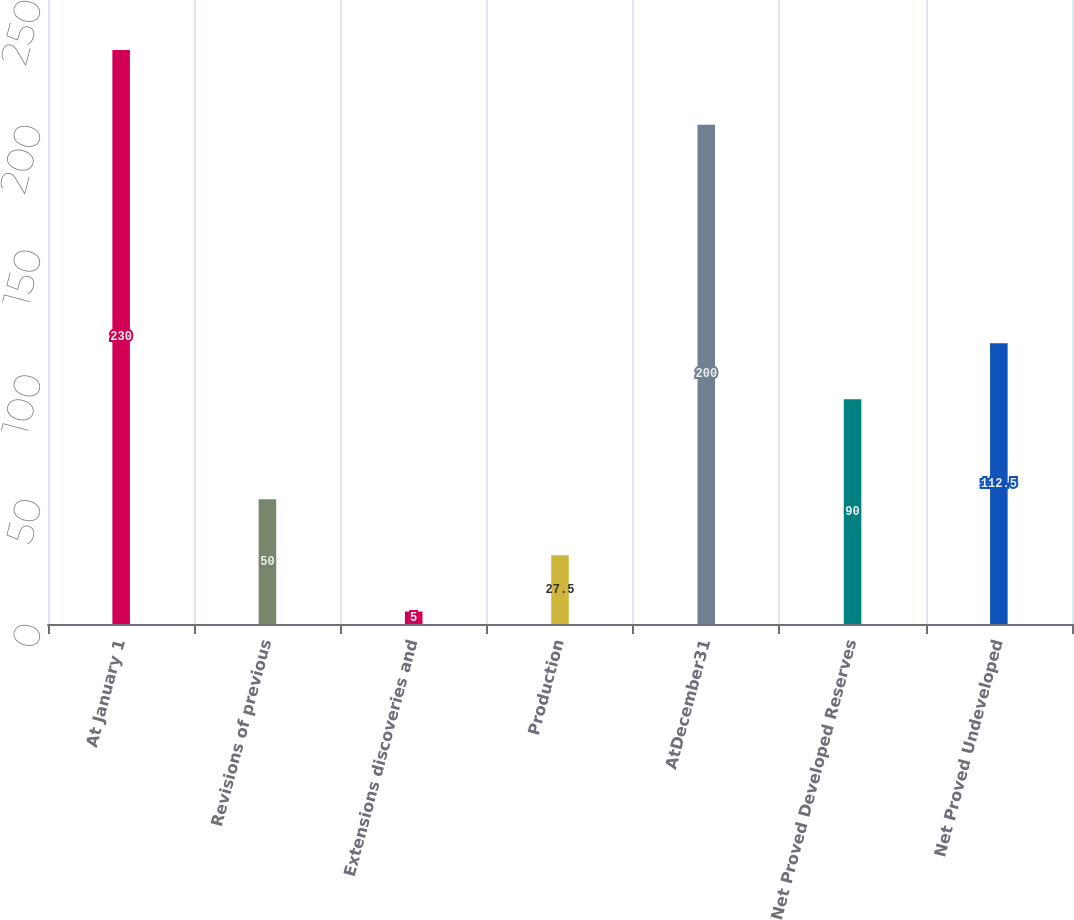Convert chart. <chart><loc_0><loc_0><loc_500><loc_500><bar_chart><fcel>At January 1<fcel>Revisions of previous<fcel>Extensions discoveries and<fcel>Production<fcel>AtDecember31<fcel>Net Proved Developed Reserves<fcel>Net Proved Undeveloped<nl><fcel>230<fcel>50<fcel>5<fcel>27.5<fcel>200<fcel>90<fcel>112.5<nl></chart> 